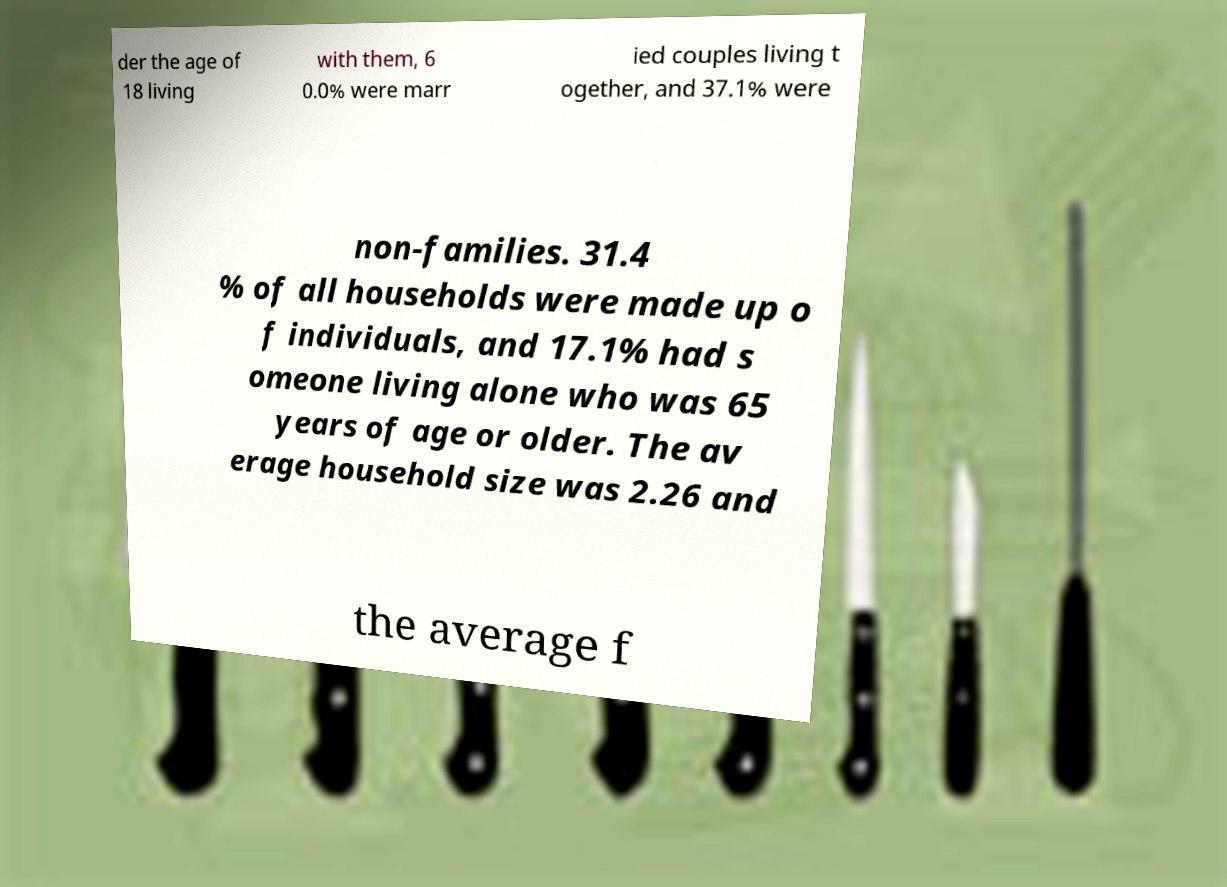What messages or text are displayed in this image? I need them in a readable, typed format. der the age of 18 living with them, 6 0.0% were marr ied couples living t ogether, and 37.1% were non-families. 31.4 % of all households were made up o f individuals, and 17.1% had s omeone living alone who was 65 years of age or older. The av erage household size was 2.26 and the average f 